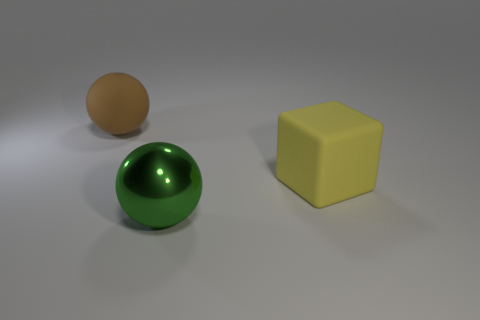Subtract all purple cubes. Subtract all brown cylinders. How many cubes are left? 1 Add 3 big purple metallic balls. How many objects exist? 6 Subtract all balls. How many objects are left? 1 Add 1 yellow cubes. How many yellow cubes exist? 2 Subtract 0 green blocks. How many objects are left? 3 Subtract all tiny purple metallic blocks. Subtract all yellow rubber things. How many objects are left? 2 Add 1 blocks. How many blocks are left? 2 